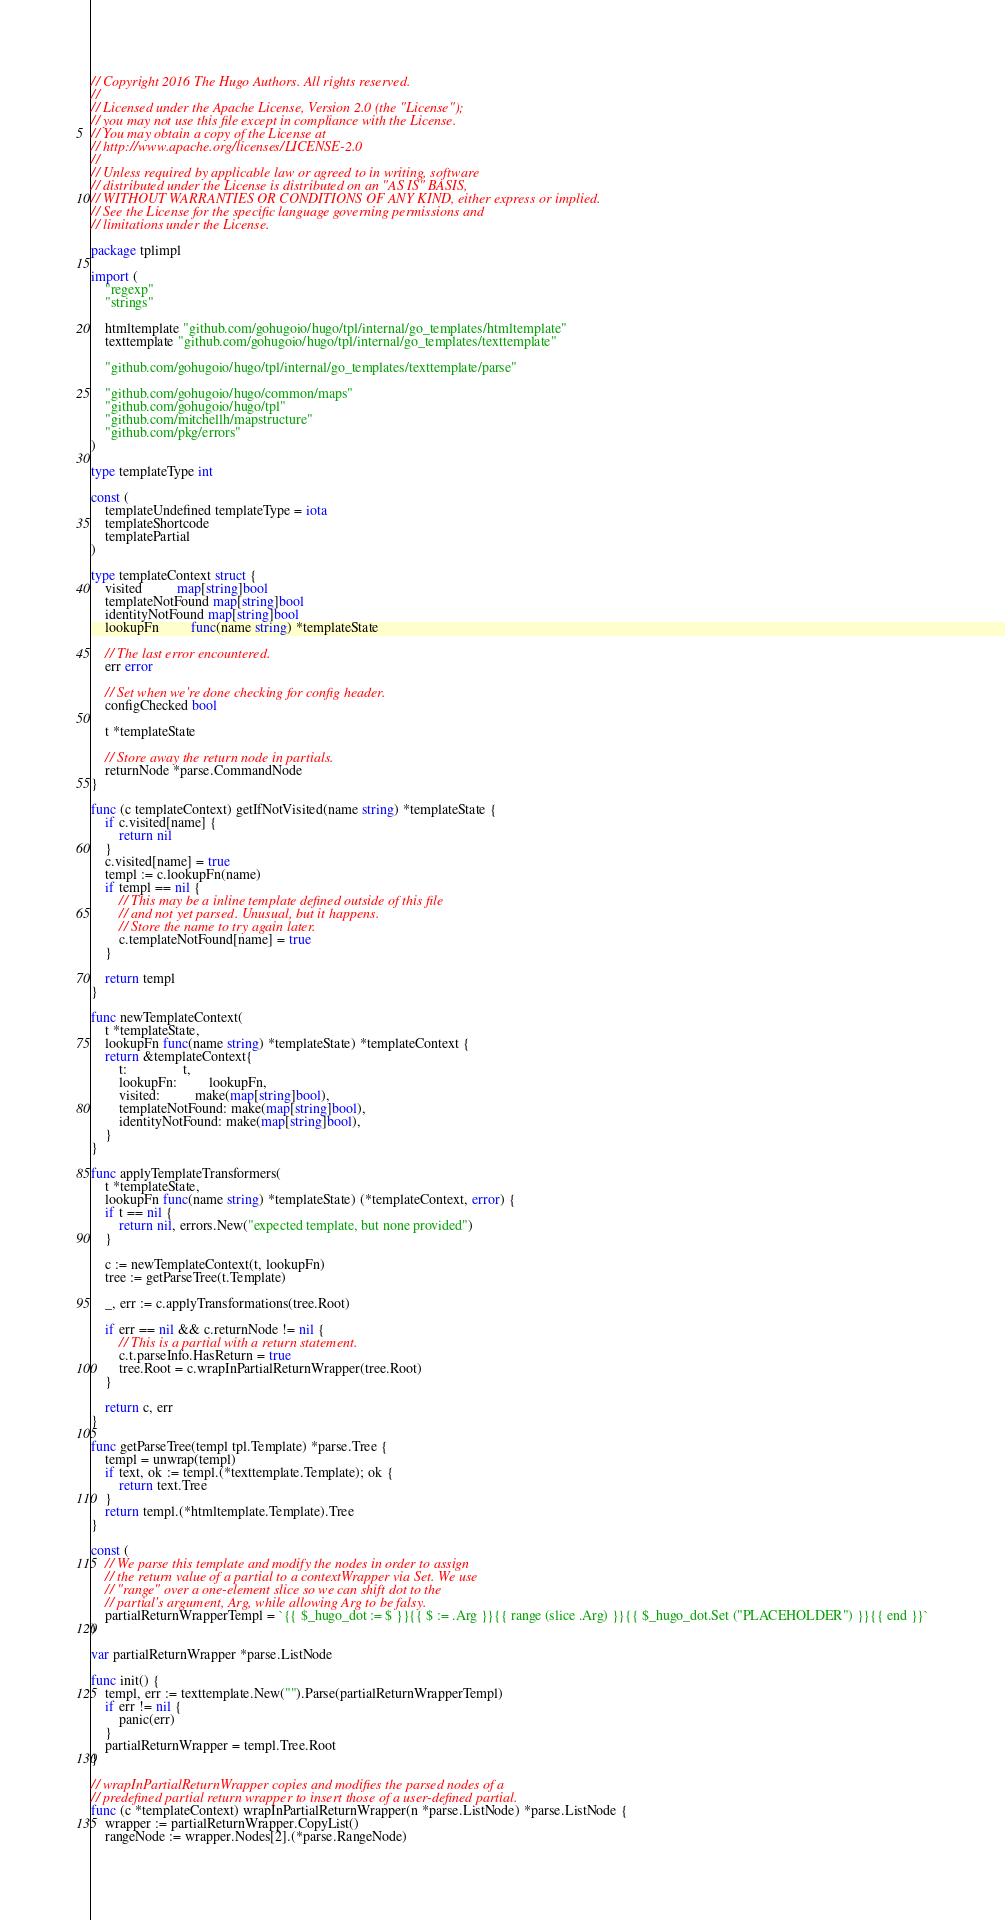Convert code to text. <code><loc_0><loc_0><loc_500><loc_500><_Go_>// Copyright 2016 The Hugo Authors. All rights reserved.
//
// Licensed under the Apache License, Version 2.0 (the "License");
// you may not use this file except in compliance with the License.
// You may obtain a copy of the License at
// http://www.apache.org/licenses/LICENSE-2.0
//
// Unless required by applicable law or agreed to in writing, software
// distributed under the License is distributed on an "AS IS" BASIS,
// WITHOUT WARRANTIES OR CONDITIONS OF ANY KIND, either express or implied.
// See the License for the specific language governing permissions and
// limitations under the License.

package tplimpl

import (
	"regexp"
	"strings"

	htmltemplate "github.com/gohugoio/hugo/tpl/internal/go_templates/htmltemplate"
	texttemplate "github.com/gohugoio/hugo/tpl/internal/go_templates/texttemplate"

	"github.com/gohugoio/hugo/tpl/internal/go_templates/texttemplate/parse"

	"github.com/gohugoio/hugo/common/maps"
	"github.com/gohugoio/hugo/tpl"
	"github.com/mitchellh/mapstructure"
	"github.com/pkg/errors"
)

type templateType int

const (
	templateUndefined templateType = iota
	templateShortcode
	templatePartial
)

type templateContext struct {
	visited          map[string]bool
	templateNotFound map[string]bool
	identityNotFound map[string]bool
	lookupFn         func(name string) *templateState

	// The last error encountered.
	err error

	// Set when we're done checking for config header.
	configChecked bool

	t *templateState

	// Store away the return node in partials.
	returnNode *parse.CommandNode
}

func (c templateContext) getIfNotVisited(name string) *templateState {
	if c.visited[name] {
		return nil
	}
	c.visited[name] = true
	templ := c.lookupFn(name)
	if templ == nil {
		// This may be a inline template defined outside of this file
		// and not yet parsed. Unusual, but it happens.
		// Store the name to try again later.
		c.templateNotFound[name] = true
	}

	return templ
}

func newTemplateContext(
	t *templateState,
	lookupFn func(name string) *templateState) *templateContext {
	return &templateContext{
		t:                t,
		lookupFn:         lookupFn,
		visited:          make(map[string]bool),
		templateNotFound: make(map[string]bool),
		identityNotFound: make(map[string]bool),
	}
}

func applyTemplateTransformers(
	t *templateState,
	lookupFn func(name string) *templateState) (*templateContext, error) {
	if t == nil {
		return nil, errors.New("expected template, but none provided")
	}

	c := newTemplateContext(t, lookupFn)
	tree := getParseTree(t.Template)

	_, err := c.applyTransformations(tree.Root)

	if err == nil && c.returnNode != nil {
		// This is a partial with a return statement.
		c.t.parseInfo.HasReturn = true
		tree.Root = c.wrapInPartialReturnWrapper(tree.Root)
	}

	return c, err
}

func getParseTree(templ tpl.Template) *parse.Tree {
	templ = unwrap(templ)
	if text, ok := templ.(*texttemplate.Template); ok {
		return text.Tree
	}
	return templ.(*htmltemplate.Template).Tree
}

const (
	// We parse this template and modify the nodes in order to assign
	// the return value of a partial to a contextWrapper via Set. We use
	// "range" over a one-element slice so we can shift dot to the
	// partial's argument, Arg, while allowing Arg to be falsy.
	partialReturnWrapperTempl = `{{ $_hugo_dot := $ }}{{ $ := .Arg }}{{ range (slice .Arg) }}{{ $_hugo_dot.Set ("PLACEHOLDER") }}{{ end }}`
)

var partialReturnWrapper *parse.ListNode

func init() {
	templ, err := texttemplate.New("").Parse(partialReturnWrapperTempl)
	if err != nil {
		panic(err)
	}
	partialReturnWrapper = templ.Tree.Root
}

// wrapInPartialReturnWrapper copies and modifies the parsed nodes of a
// predefined partial return wrapper to insert those of a user-defined partial.
func (c *templateContext) wrapInPartialReturnWrapper(n *parse.ListNode) *parse.ListNode {
	wrapper := partialReturnWrapper.CopyList()
	rangeNode := wrapper.Nodes[2].(*parse.RangeNode)</code> 